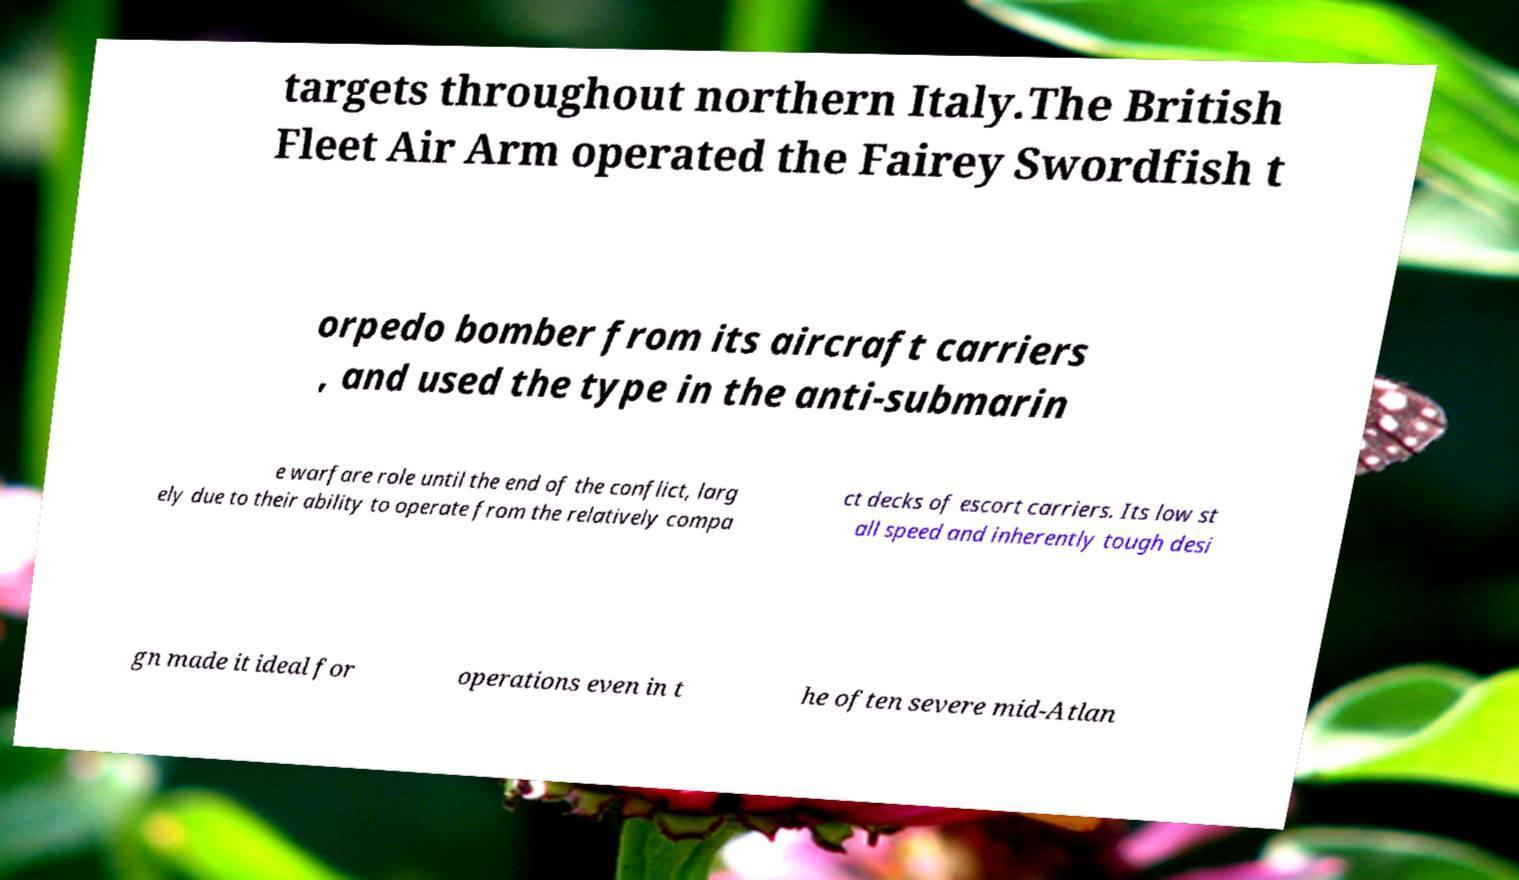For documentation purposes, I need the text within this image transcribed. Could you provide that? targets throughout northern Italy.The British Fleet Air Arm operated the Fairey Swordfish t orpedo bomber from its aircraft carriers , and used the type in the anti-submarin e warfare role until the end of the conflict, larg ely due to their ability to operate from the relatively compa ct decks of escort carriers. Its low st all speed and inherently tough desi gn made it ideal for operations even in t he often severe mid-Atlan 